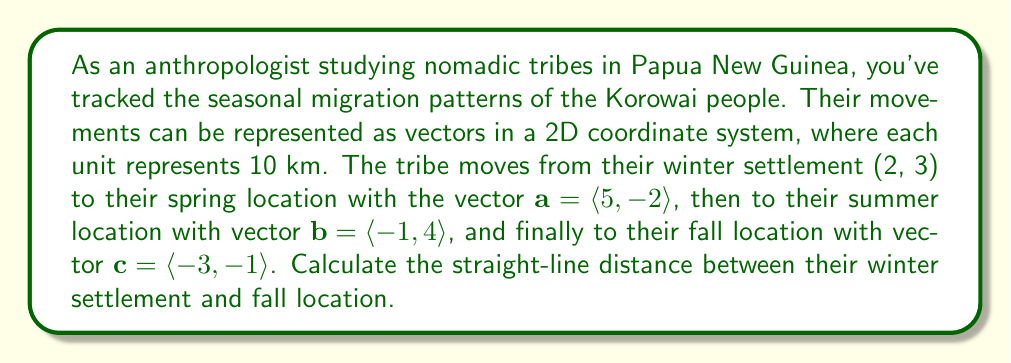Solve this math problem. To solve this problem, we need to follow these steps:

1) First, we need to find the total displacement vector from the winter settlement to the fall location. This can be done by adding all the movement vectors:

   $\mathbf{d} = \mathbf{a} + \mathbf{b} + \mathbf{c}$

2) Let's calculate this:
   
   $\mathbf{d} = \langle 5, -2 \rangle + \langle -1, 4 \rangle + \langle -3, -1 \rangle$
   $\mathbf{d} = \langle 5-1-3, -2+4-1 \rangle$
   $\mathbf{d} = \langle 1, 1 \rangle$

3) Now, we need to find the coordinates of the fall location. We can do this by adding the displacement vector to the winter settlement coordinates:

   Fall location = $(2, 3) + \langle 1, 1 \rangle = (3, 4)$

4) To find the straight-line distance, we need to calculate the magnitude of the vector from (2, 3) to (3, 4). We can do this by subtracting the coordinates and using the distance formula:

   Distance vector = $(3-2, 4-3) = \langle 1, 1 \rangle$

5) The straight-line distance is the magnitude of this vector:

   $d = \sqrt{1^2 + 1^2} = \sqrt{2}$

6) Remember that each unit represents 10 km, so we need to multiply our result by 10:

   Actual distance = $10\sqrt{2}$ km
Answer: The straight-line distance between the Korowai tribe's winter settlement and fall location is $10\sqrt{2}$ km. 